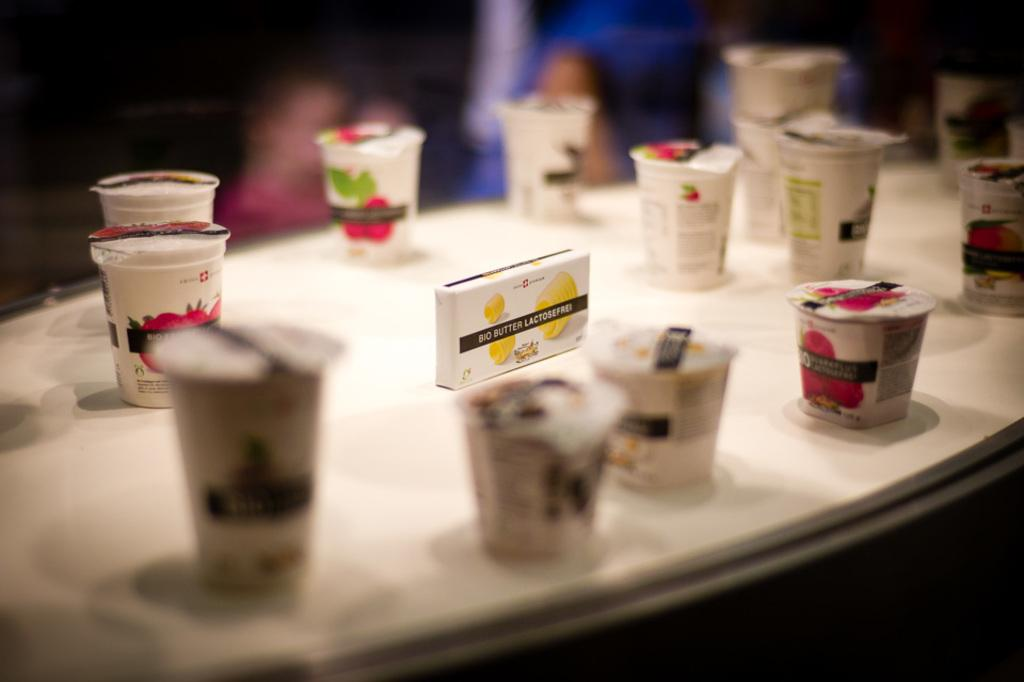What piece of furniture is visible in the image? There is a table in the image. What objects are placed on the table? There are cups on the table. Can you describe the background of the image? The background of the image is blurry. What type of eggnog is being served in the cups on the table? There is no mention of eggnog in the image, and it is not possible to determine the contents of the cups from the provided facts. 